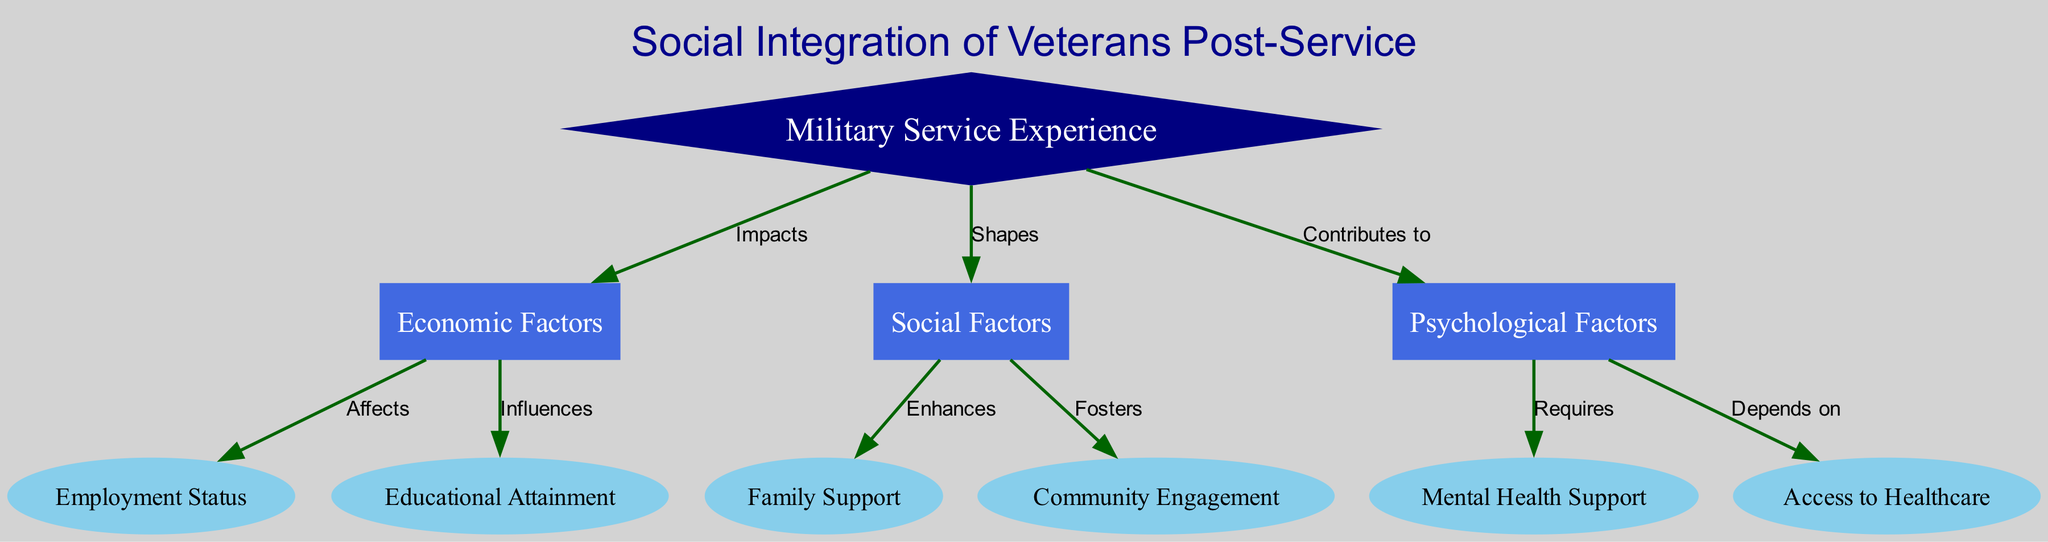What's the total number of nodes in the diagram? The diagram includes 10 distinct nodes, each representing different factors in the social integration of veterans.
Answer: 10 What is the main impact of "Military Service Experience"? "Military Service Experience" impacts "Economic Factors" as indicated by the directed edge labeled "Impacts" connecting the two nodes.
Answer: Economic Factors Which node is influenced by "Economic Factors"? "Economic Factors" influences both "Employment Status" and "Educational Attainment", but we are specifically looking for a single answer; the first one influenced is "Employment Status".
Answer: Employment Status How does "Family Support" relate to "Social Factors"? "Family Support" is enhanced by "Social Factors" as shown by the edge that connects them labeled "Enhances".
Answer: Enhances What psychological factor is dependent on "Mental Health Support"? The psychological factor that depends on "Mental Health Support" is "Psychological Factors", as indicated by the directed edge labeled "Requires".
Answer: Psychological Factors What are the two nodes affected by "Psychological Factors"? "Psychological Factors" affects "Mental Health Support" and "Access to Healthcare". We can see two edges leading out from it indicating these relationships.
Answer: Mental Health Support, Access to Healthcare Which factor is shaped by "Military Service Experience"? The "Social Factors" node is shaped by "Military Service Experience", indicating how the experiences in service influence social interactions.
Answer: Social Factors Which factors enhance community engagement? "Community Engagement" is fostered by "Social Factors", indicating the direct relationship between them.
Answer: Social Factors 